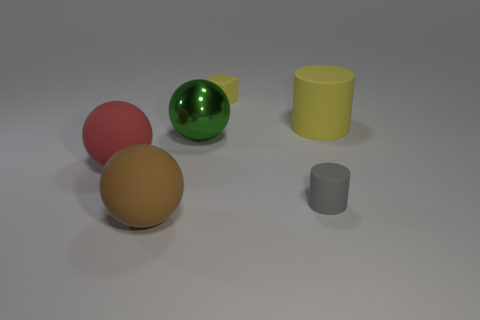What shape is the large thing left of the large rubber sphere in front of the big red matte sphere left of the big metal object?
Provide a succinct answer. Sphere. Do the big green object and the large rubber object that is on the left side of the brown thing have the same shape?
Your response must be concise. Yes. How many large objects are green metallic things or yellow cylinders?
Keep it short and to the point. 2. Is there a brown rubber thing that has the same size as the metal thing?
Offer a terse response. Yes. What is the color of the thing that is behind the yellow thing that is in front of the yellow matte thing to the left of the yellow rubber cylinder?
Offer a terse response. Yellow. Is the material of the tiny yellow thing the same as the small thing in front of the large green metallic sphere?
Give a very brief answer. Yes. What is the size of the brown matte thing that is the same shape as the big shiny thing?
Give a very brief answer. Large. Are there an equal number of big matte cylinders that are behind the tiny yellow rubber block and big green spheres behind the large matte cylinder?
Ensure brevity in your answer.  Yes. What number of other things are the same material as the yellow cube?
Provide a succinct answer. 4. Is the number of tiny yellow things that are in front of the large red rubber thing the same as the number of big brown rubber balls?
Provide a succinct answer. No. 